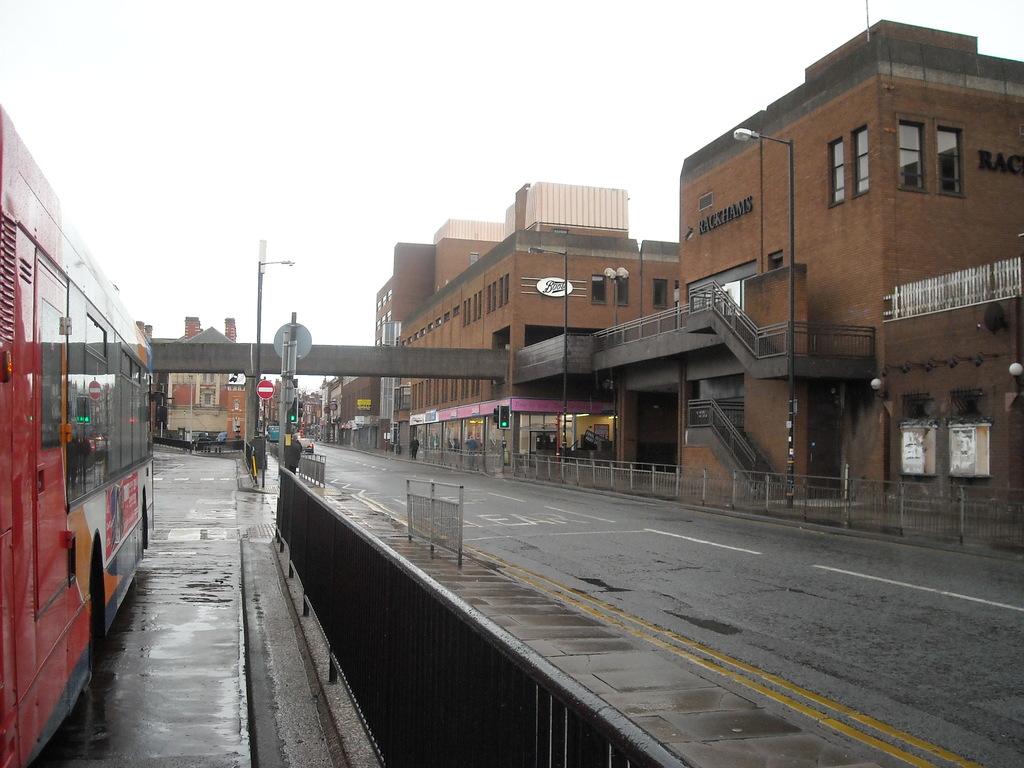What's the building on the right say?
Offer a terse response. Rackhams. 